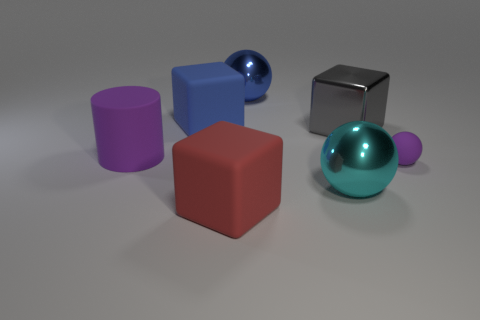What material is the blue thing that is to the left of the blue metal sphere?
Provide a succinct answer. Rubber. The shiny cube is what color?
Offer a very short reply. Gray. Is the size of the block in front of the purple matte cylinder the same as the tiny rubber ball?
Give a very brief answer. No. There is a sphere behind the blue object that is left of the big block in front of the big cylinder; what is it made of?
Offer a very short reply. Metal. There is a rubber cube behind the large red rubber cube; does it have the same color as the big metal ball that is behind the small purple matte sphere?
Offer a terse response. Yes. There is a large cyan ball in front of the big rubber block that is behind the cyan metal object; what is it made of?
Provide a succinct answer. Metal. There is another sphere that is the same size as the blue ball; what is its color?
Provide a short and direct response. Cyan. Does the large gray metallic thing have the same shape as the large rubber thing in front of the big purple rubber thing?
Provide a short and direct response. Yes. There is a thing that is the same color as the rubber sphere; what shape is it?
Your response must be concise. Cylinder. There is a big cube that is on the left side of the big matte cube that is in front of the large shiny cube; how many large gray blocks are left of it?
Ensure brevity in your answer.  0. 